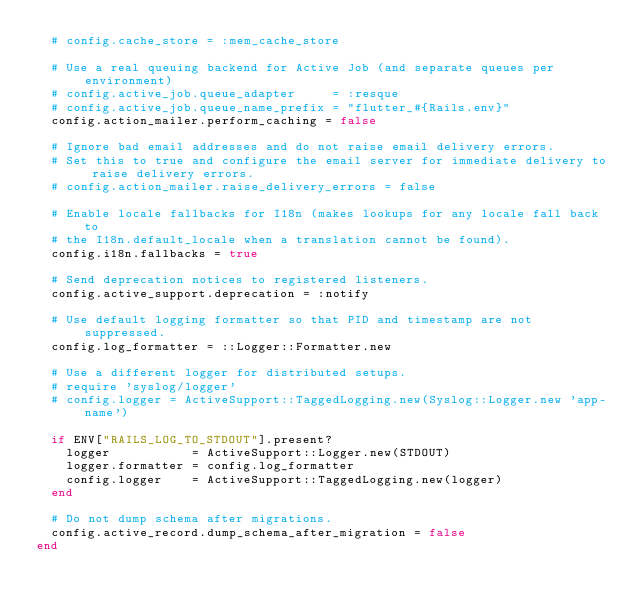<code> <loc_0><loc_0><loc_500><loc_500><_Ruby_>  # config.cache_store = :mem_cache_store

  # Use a real queuing backend for Active Job (and separate queues per environment)
  # config.active_job.queue_adapter     = :resque
  # config.active_job.queue_name_prefix = "flutter_#{Rails.env}"
  config.action_mailer.perform_caching = false

  # Ignore bad email addresses and do not raise email delivery errors.
  # Set this to true and configure the email server for immediate delivery to raise delivery errors.
  # config.action_mailer.raise_delivery_errors = false

  # Enable locale fallbacks for I18n (makes lookups for any locale fall back to
  # the I18n.default_locale when a translation cannot be found).
  config.i18n.fallbacks = true

  # Send deprecation notices to registered listeners.
  config.active_support.deprecation = :notify

  # Use default logging formatter so that PID and timestamp are not suppressed.
  config.log_formatter = ::Logger::Formatter.new

  # Use a different logger for distributed setups.
  # require 'syslog/logger'
  # config.logger = ActiveSupport::TaggedLogging.new(Syslog::Logger.new 'app-name')

  if ENV["RAILS_LOG_TO_STDOUT"].present?
    logger           = ActiveSupport::Logger.new(STDOUT)
    logger.formatter = config.log_formatter
    config.logger    = ActiveSupport::TaggedLogging.new(logger)
  end

  # Do not dump schema after migrations.
  config.active_record.dump_schema_after_migration = false
end
</code> 